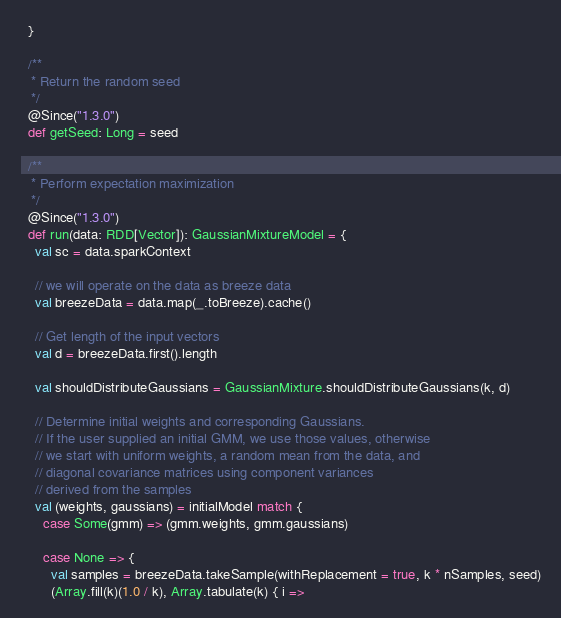<code> <loc_0><loc_0><loc_500><loc_500><_Scala_>  }

  /**
   * Return the random seed
   */
  @Since("1.3.0")
  def getSeed: Long = seed

  /**
   * Perform expectation maximization
   */
  @Since("1.3.0")
  def run(data: RDD[Vector]): GaussianMixtureModel = {
    val sc = data.sparkContext

    // we will operate on the data as breeze data
    val breezeData = data.map(_.toBreeze).cache()

    // Get length of the input vectors
    val d = breezeData.first().length

    val shouldDistributeGaussians = GaussianMixture.shouldDistributeGaussians(k, d)

    // Determine initial weights and corresponding Gaussians.
    // If the user supplied an initial GMM, we use those values, otherwise
    // we start with uniform weights, a random mean from the data, and
    // diagonal covariance matrices using component variances
    // derived from the samples
    val (weights, gaussians) = initialModel match {
      case Some(gmm) => (gmm.weights, gmm.gaussians)

      case None => {
        val samples = breezeData.takeSample(withReplacement = true, k * nSamples, seed)
        (Array.fill(k)(1.0 / k), Array.tabulate(k) { i =></code> 